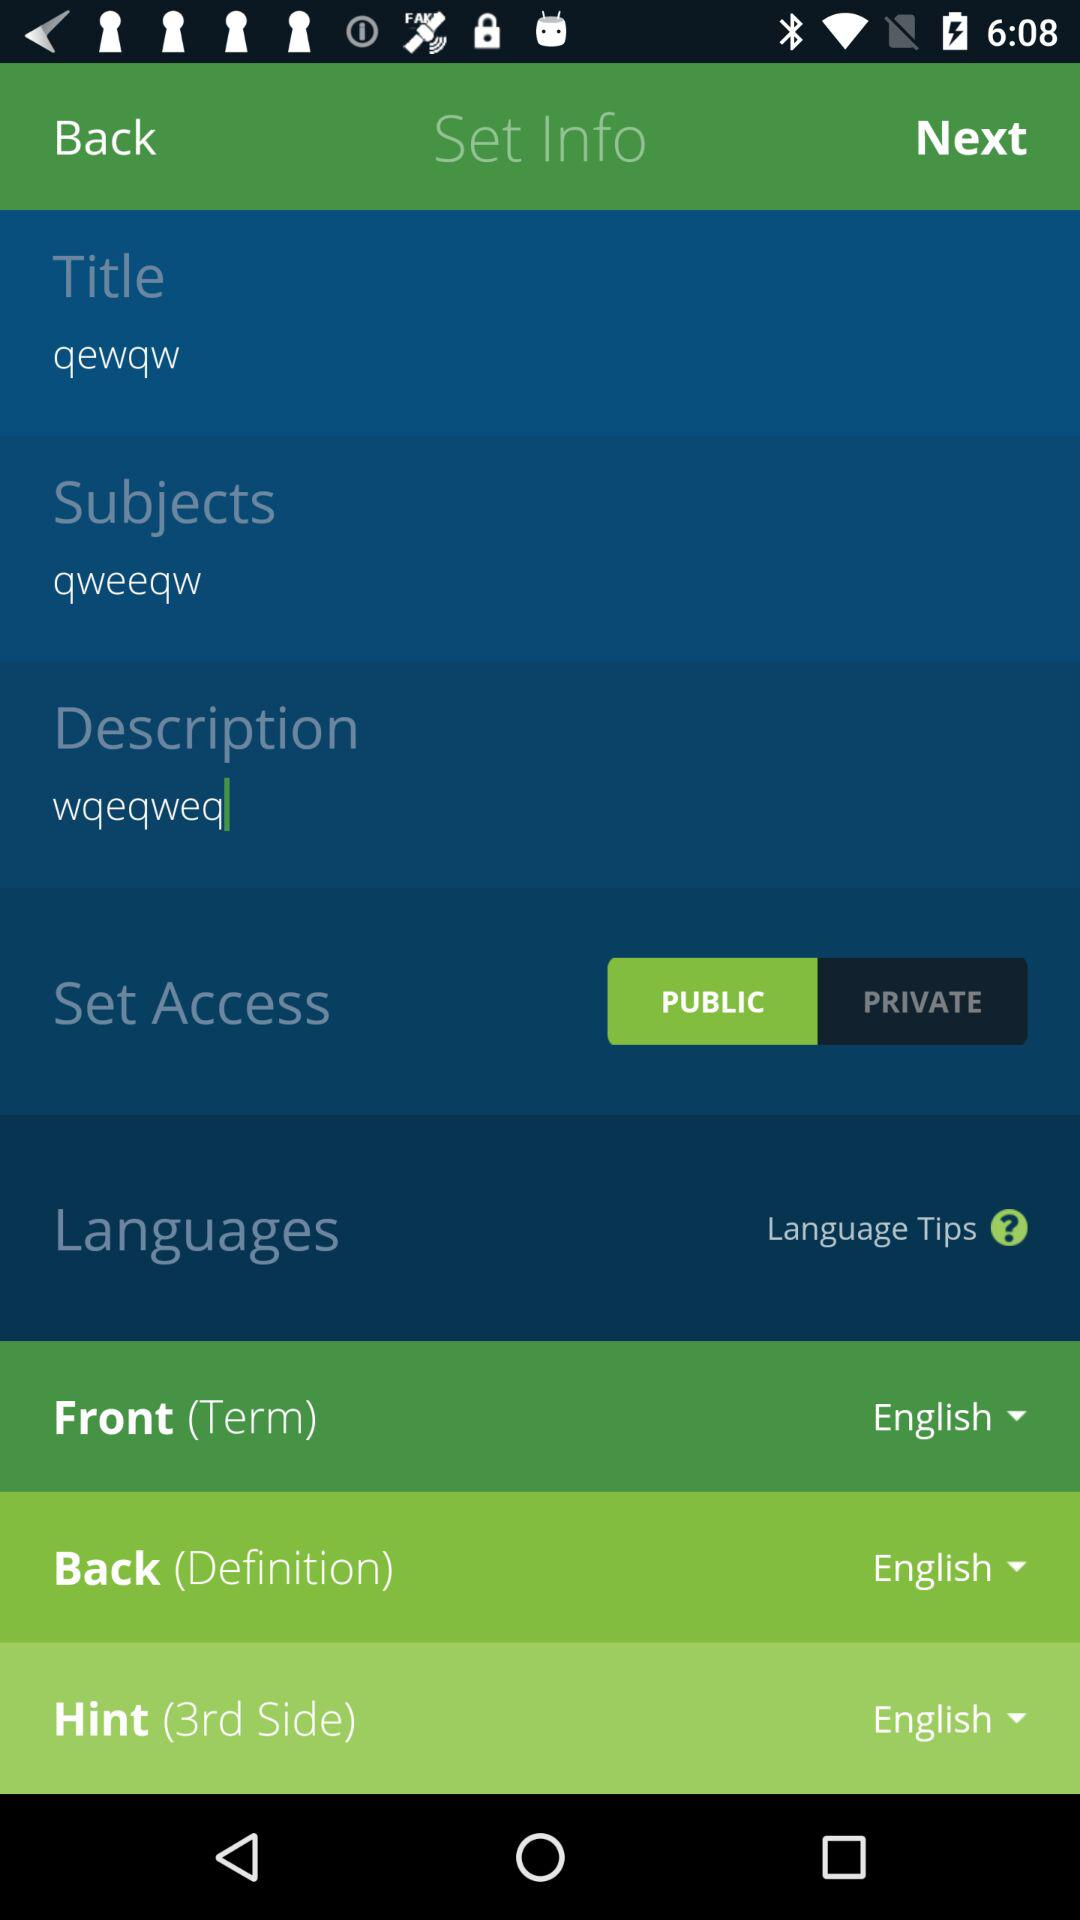Which language was selected for "Back (Definition)"? The selected language was English. 